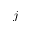Convert formula to latex. <formula><loc_0><loc_0><loc_500><loc_500>j</formula> 